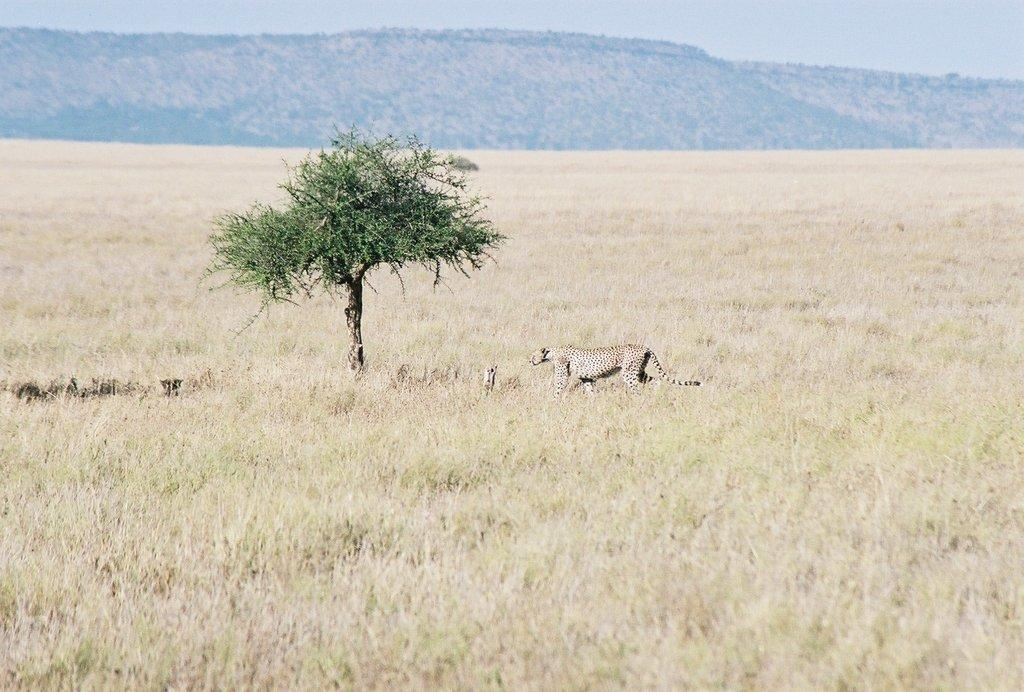What type of animal can be seen in the image? There is an animal in the image, but its specific type cannot be determined from the provided facts. What type of vegetation is present in the image? There is grass and a tree in the image. What geographical feature is visible in the image? There is a mountain in the image. What part of the natural environment is visible in the image? The sky is visible in the image. Where is the drain located in the image? There is no drain present in the image. What type of pets can be seen in the image? There is no mention of pets in the image. What news is being reported in the image? There is no news or any indication of news reporting in the image. 